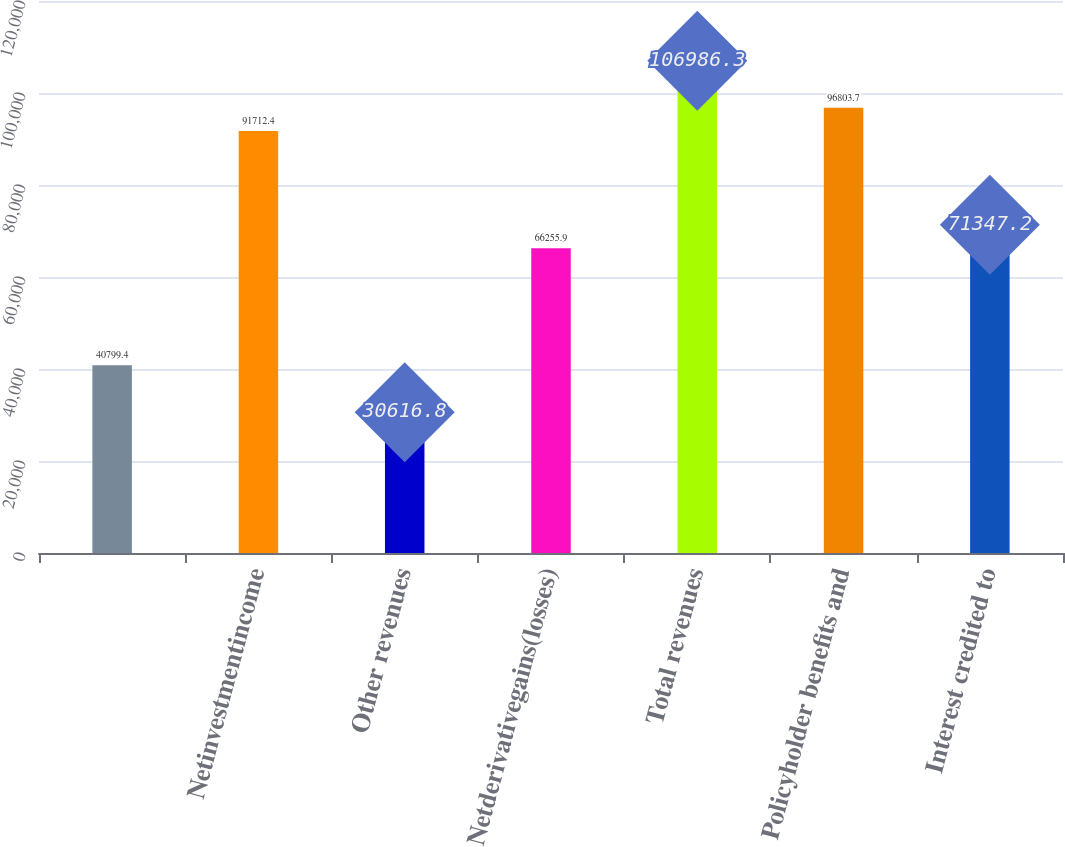Convert chart. <chart><loc_0><loc_0><loc_500><loc_500><bar_chart><ecel><fcel>Netinvestmentincome<fcel>Other revenues<fcel>Netderivativegains(losses)<fcel>Total revenues<fcel>Policyholder benefits and<fcel>Interest credited to<nl><fcel>40799.4<fcel>91712.4<fcel>30616.8<fcel>66255.9<fcel>106986<fcel>96803.7<fcel>71347.2<nl></chart> 